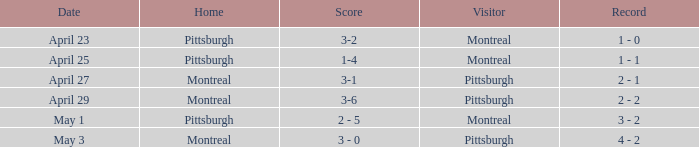Who visited on April 29? Pittsburgh. 